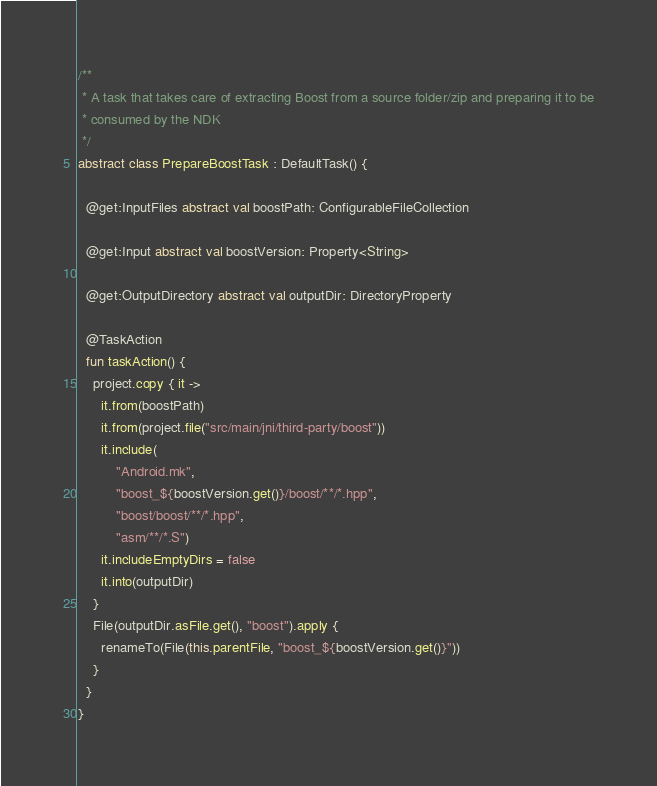<code> <loc_0><loc_0><loc_500><loc_500><_Kotlin_>/**
 * A task that takes care of extracting Boost from a source folder/zip and preparing it to be
 * consumed by the NDK
 */
abstract class PrepareBoostTask : DefaultTask() {

  @get:InputFiles abstract val boostPath: ConfigurableFileCollection

  @get:Input abstract val boostVersion: Property<String>

  @get:OutputDirectory abstract val outputDir: DirectoryProperty

  @TaskAction
  fun taskAction() {
    project.copy { it ->
      it.from(boostPath)
      it.from(project.file("src/main/jni/third-party/boost"))
      it.include(
          "Android.mk",
          "boost_${boostVersion.get()}/boost/**/*.hpp",
          "boost/boost/**/*.hpp",
          "asm/**/*.S")
      it.includeEmptyDirs = false
      it.into(outputDir)
    }
    File(outputDir.asFile.get(), "boost").apply {
      renameTo(File(this.parentFile, "boost_${boostVersion.get()}"))
    }
  }
}
</code> 